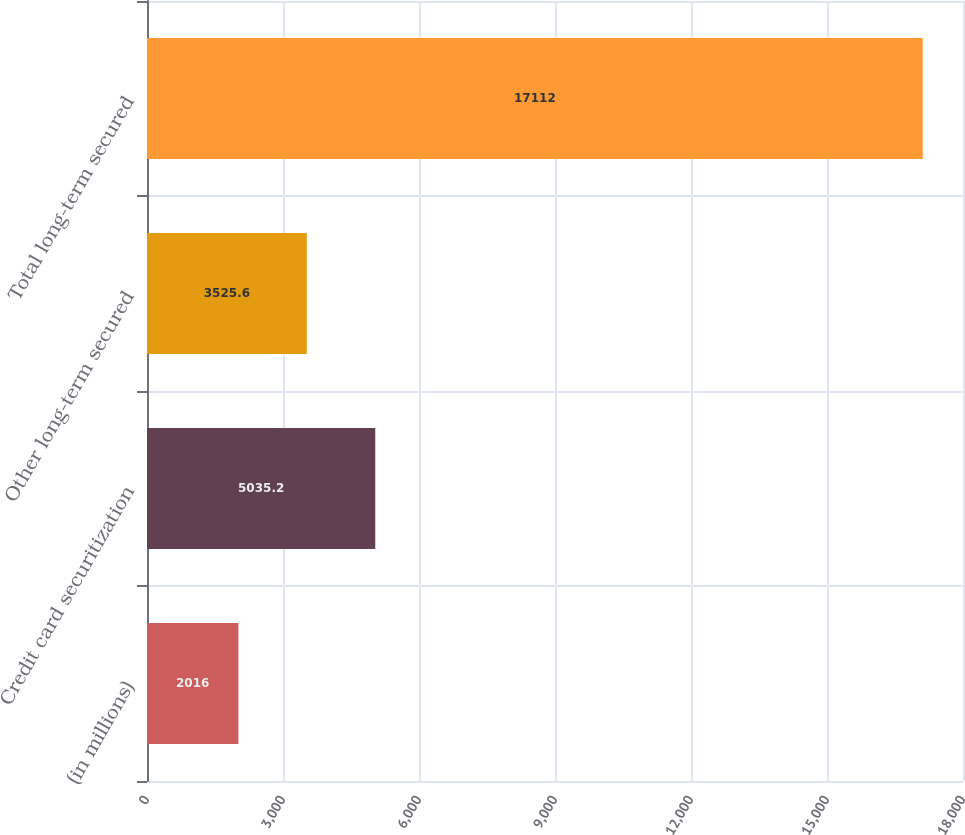<chart> <loc_0><loc_0><loc_500><loc_500><bar_chart><fcel>(in millions)<fcel>Credit card securitization<fcel>Other long-term secured<fcel>Total long-term secured<nl><fcel>2016<fcel>5035.2<fcel>3525.6<fcel>17112<nl></chart> 